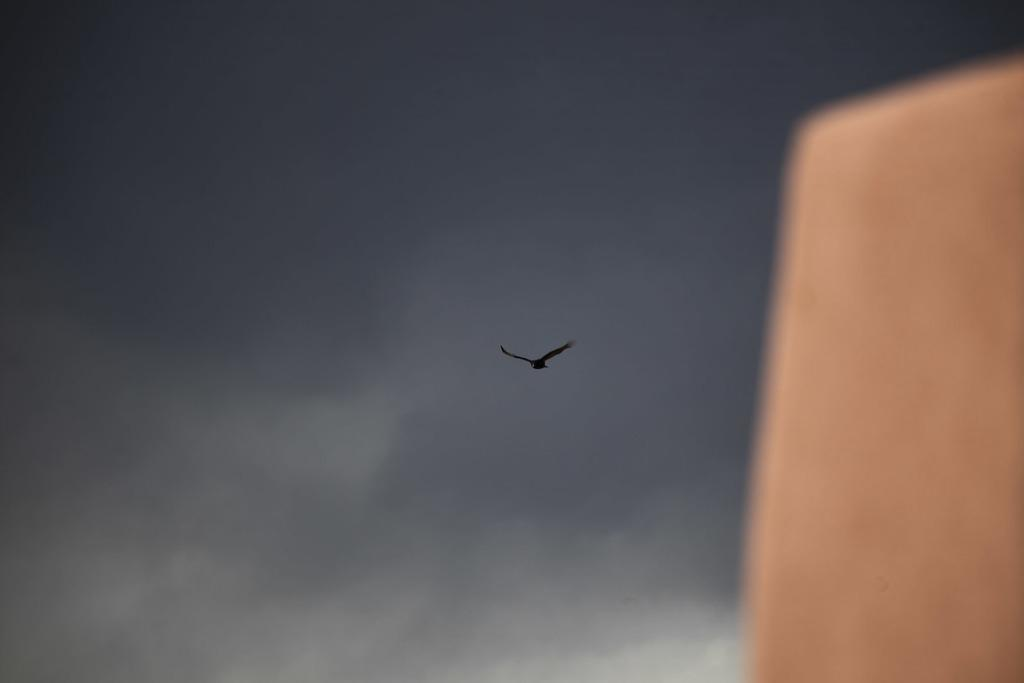What is the condition of the sky in the image? The sky in the image is cloudy. Can you describe any activity happening in the sky? Yes, a bird is flying in the sky. What can be seen on the right side of the image? There is an object on the right side of the image. How many clams are holding onto the bird in the image? There are no clams present in the image, and therefore none are holding onto the bird. 